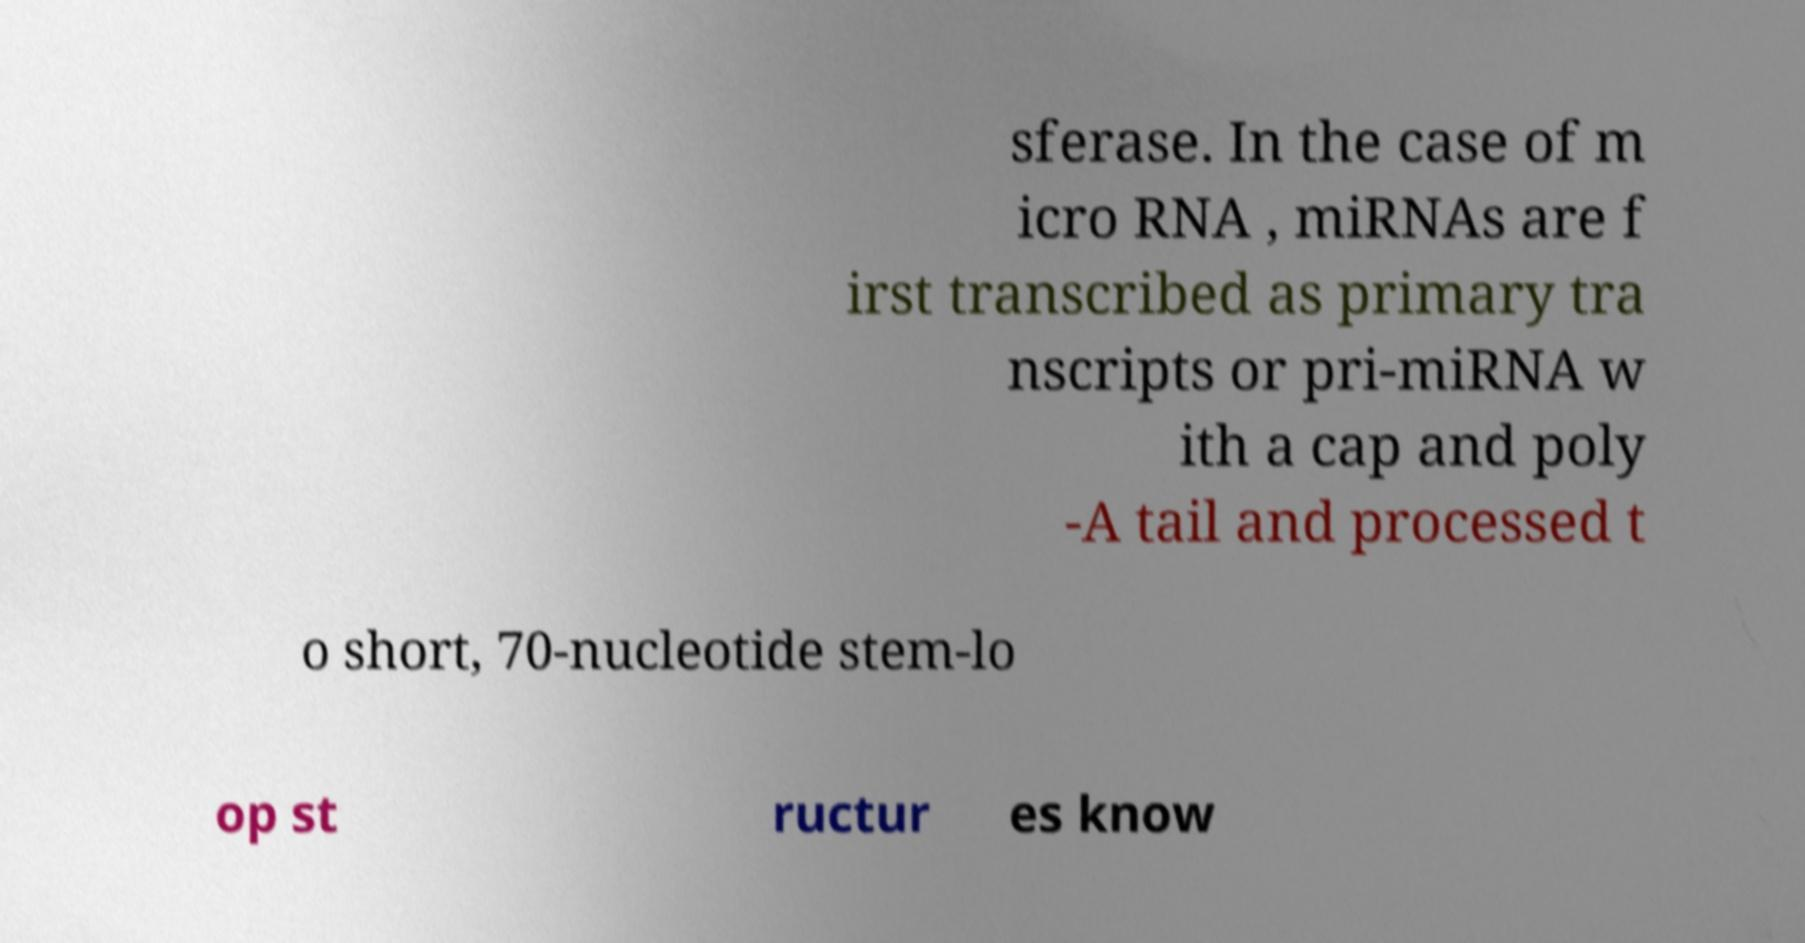Could you extract and type out the text from this image? sferase. In the case of m icro RNA , miRNAs are f irst transcribed as primary tra nscripts or pri-miRNA w ith a cap and poly -A tail and processed t o short, 70-nucleotide stem-lo op st ructur es know 